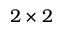<formula> <loc_0><loc_0><loc_500><loc_500>2 \times 2</formula> 